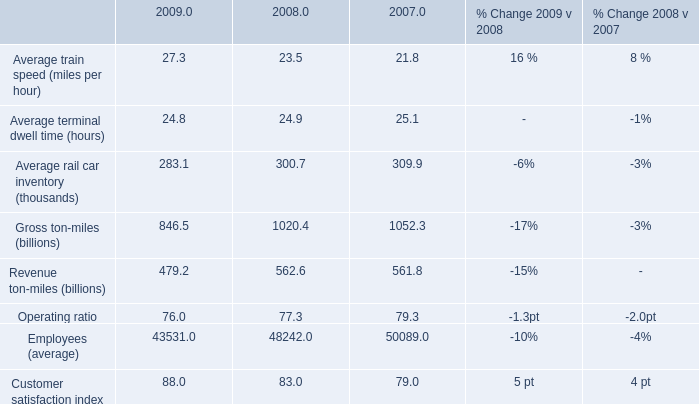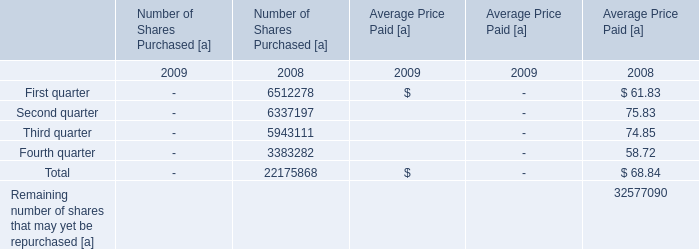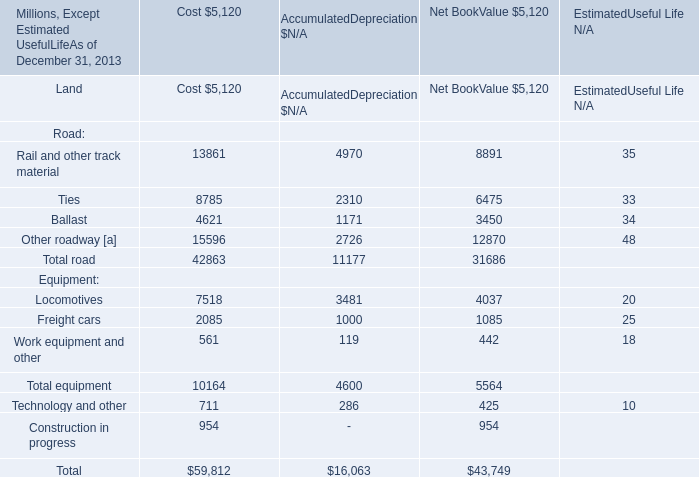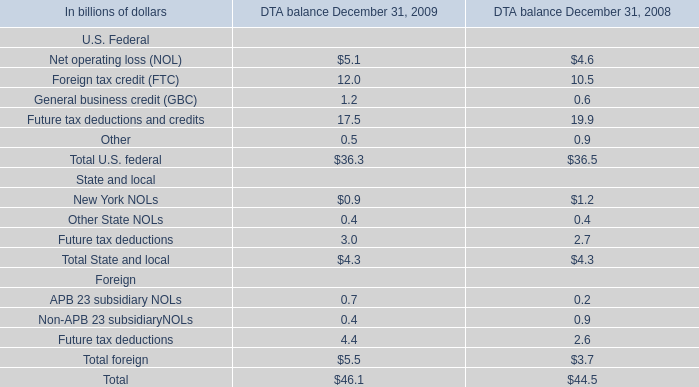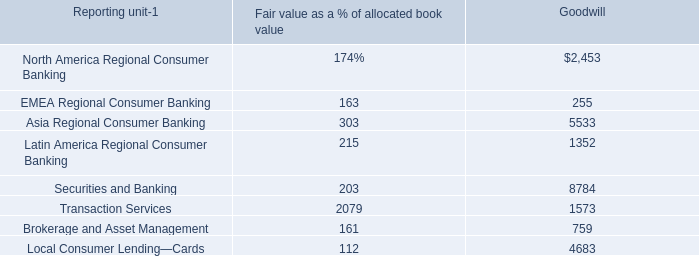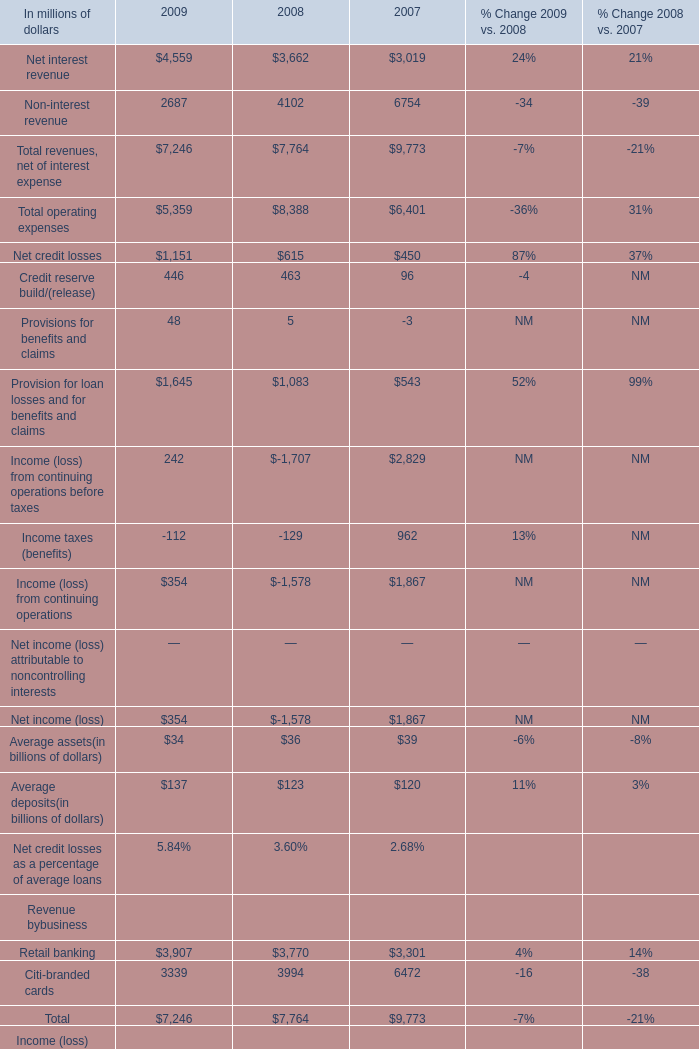How many Road exceed the average of Road in 2013? 
Answer: 6. 